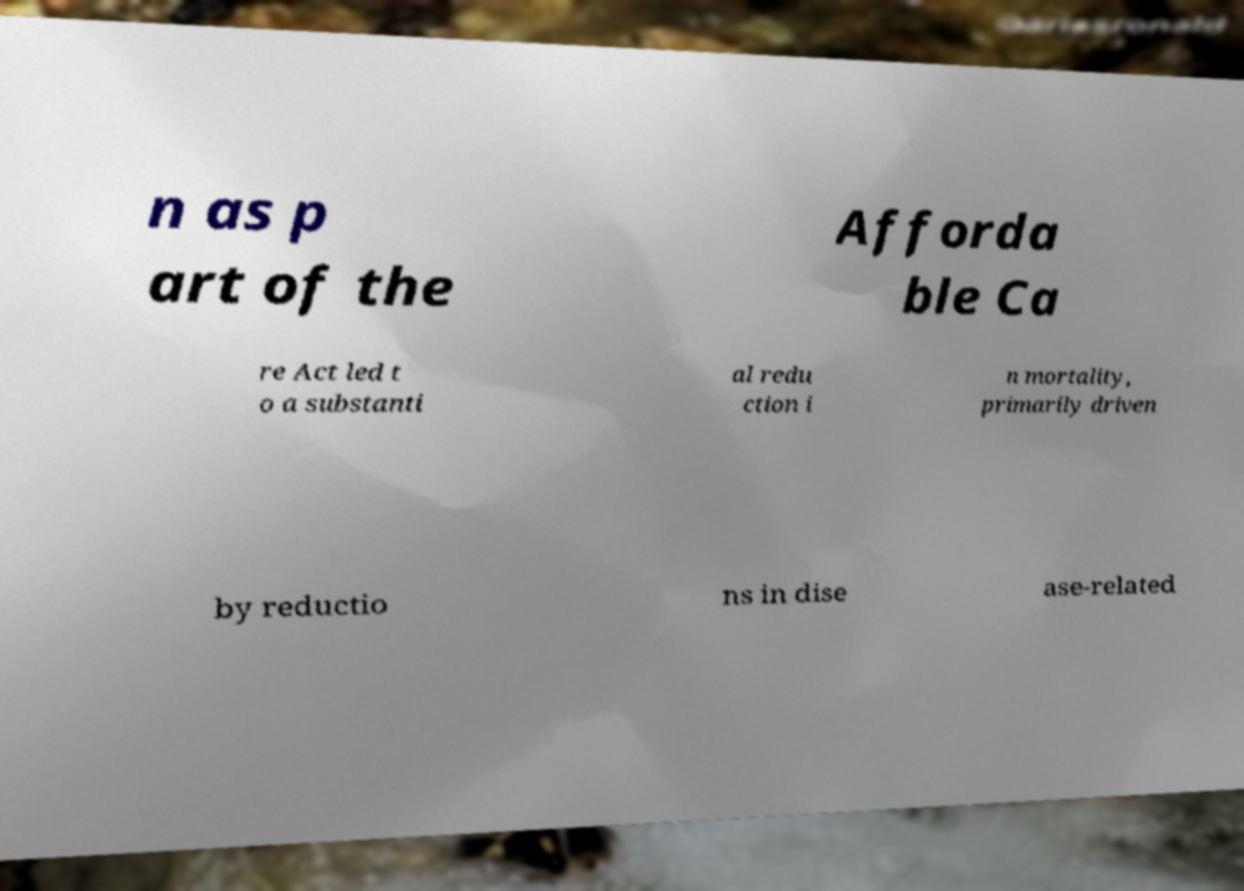Please identify and transcribe the text found in this image. n as p art of the Afforda ble Ca re Act led t o a substanti al redu ction i n mortality, primarily driven by reductio ns in dise ase-related 